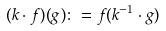<formula> <loc_0><loc_0><loc_500><loc_500>( k \cdot f ) ( g ) \colon = f ( k ^ { - 1 } \cdot g )</formula> 